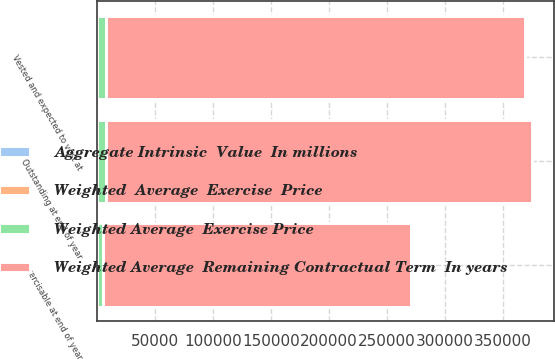Convert chart to OTSL. <chart><loc_0><loc_0><loc_500><loc_500><stacked_bar_chart><ecel><fcel>Outstanding at end of year<fcel>Vested and expected to vest at<fcel>Exercisable at end of year<nl><fcel>Weighted Average  Remaining Contractual Term  In years<fcel>367339<fcel>361496<fcel>265366<nl><fcel>Weighted  Average  Exercise  Price<fcel>33<fcel>33<fcel>33<nl><fcel>Aggregate Intrinsic  Value  In millions<fcel>4.2<fcel>4.2<fcel>3.4<nl><fcel>Weighted Average  Exercise Price<fcel>7375<fcel>7256<fcel>5298<nl></chart> 